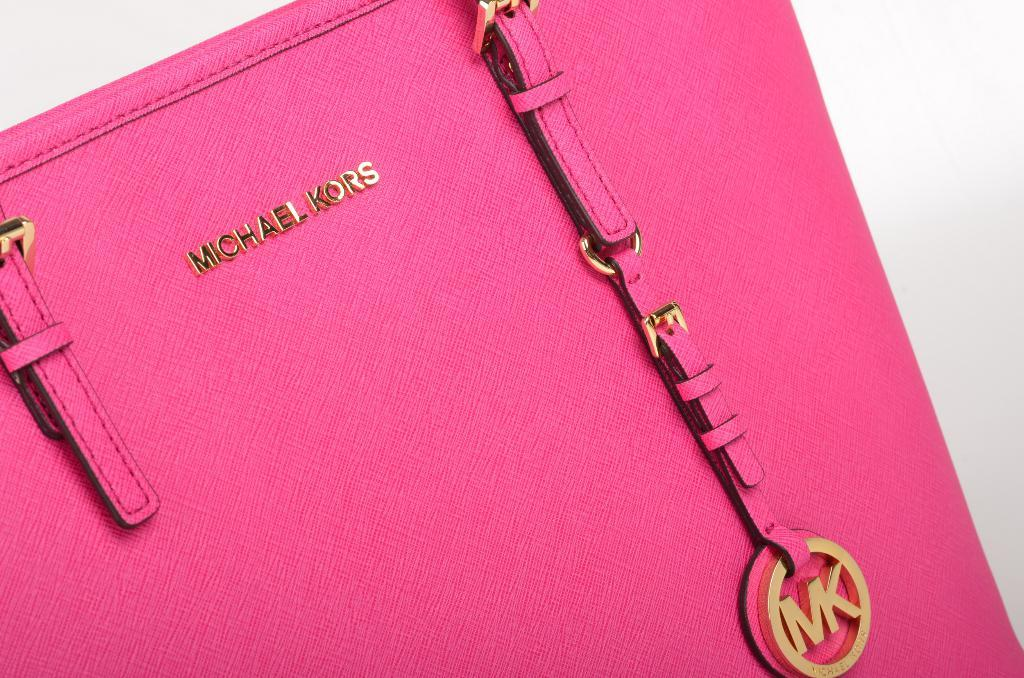What object is present in the image? There is a bag in the image. What color is the bag? The bag is pink in color. Are there any words or letters on the bag? Yes, there is text written on the bag. How many toads are sitting on the bag in the image? There are no toads present in the image. What type of fold can be seen in the bag in the image? The image does not show any folds in the bag. 